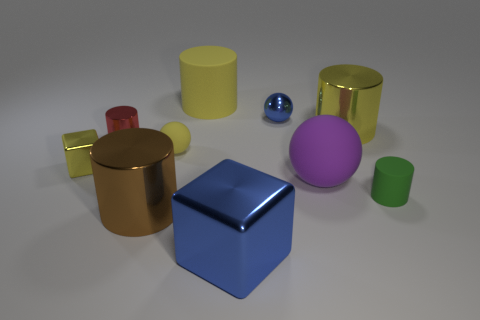What number of tiny red cylinders are in front of the blue block to the left of the ball that is in front of the tiny yellow shiny block?
Your response must be concise. 0. There is a small rubber object on the right side of the big blue block; is it the same shape as the blue metal thing that is behind the tiny red object?
Offer a terse response. No. What number of things are yellow cubes or red things?
Your answer should be very brief. 2. What material is the small thing behind the large metal object that is behind the brown metallic cylinder made of?
Keep it short and to the point. Metal. Is there a big cylinder that has the same color as the large metal block?
Keep it short and to the point. No. There is a rubber sphere that is the same size as the red thing; what color is it?
Your response must be concise. Yellow. There is a blue object behind the rubber cylinder that is in front of the large thing that is on the right side of the big sphere; what is its material?
Your answer should be compact. Metal. Is the color of the large metallic block the same as the shiny block that is behind the brown metal cylinder?
Give a very brief answer. No. What number of objects are either large metal things that are left of the large rubber sphere or shiny objects that are on the right side of the tiny yellow rubber ball?
Your answer should be very brief. 4. There is a blue object behind the yellow cylinder that is on the right side of the purple ball; what is its shape?
Offer a very short reply. Sphere. 